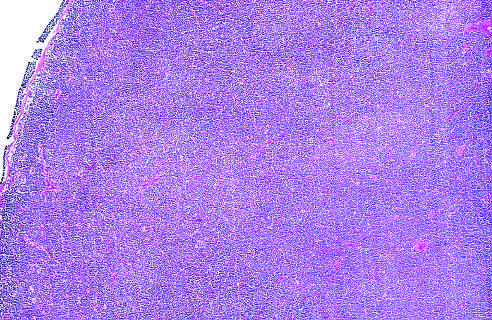does the vessel wall show diffuse effacement of nodal architecture?
Answer the question using a single word or phrase. No 